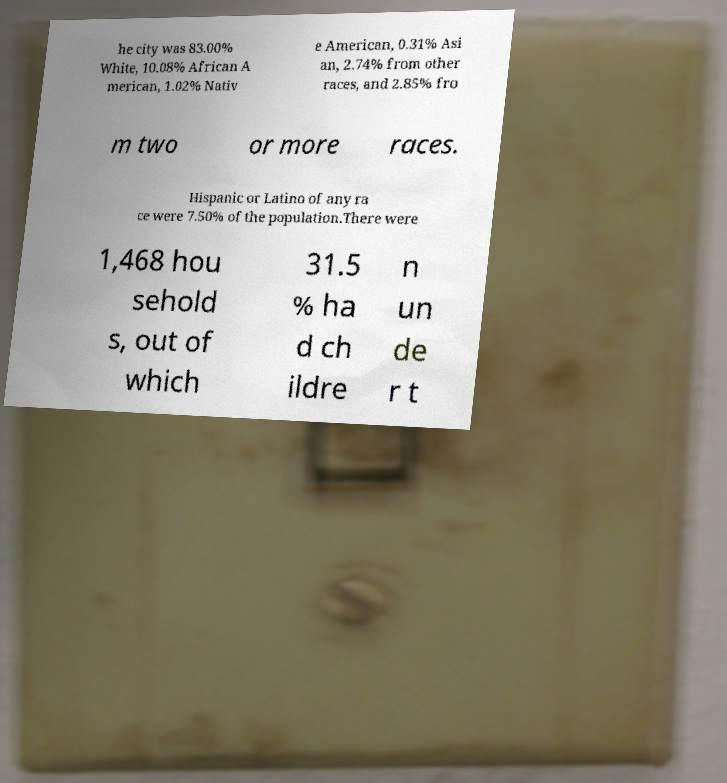Please read and relay the text visible in this image. What does it say? he city was 83.00% White, 10.08% African A merican, 1.02% Nativ e American, 0.31% Asi an, 2.74% from other races, and 2.85% fro m two or more races. Hispanic or Latino of any ra ce were 7.50% of the population.There were 1,468 hou sehold s, out of which 31.5 % ha d ch ildre n un de r t 